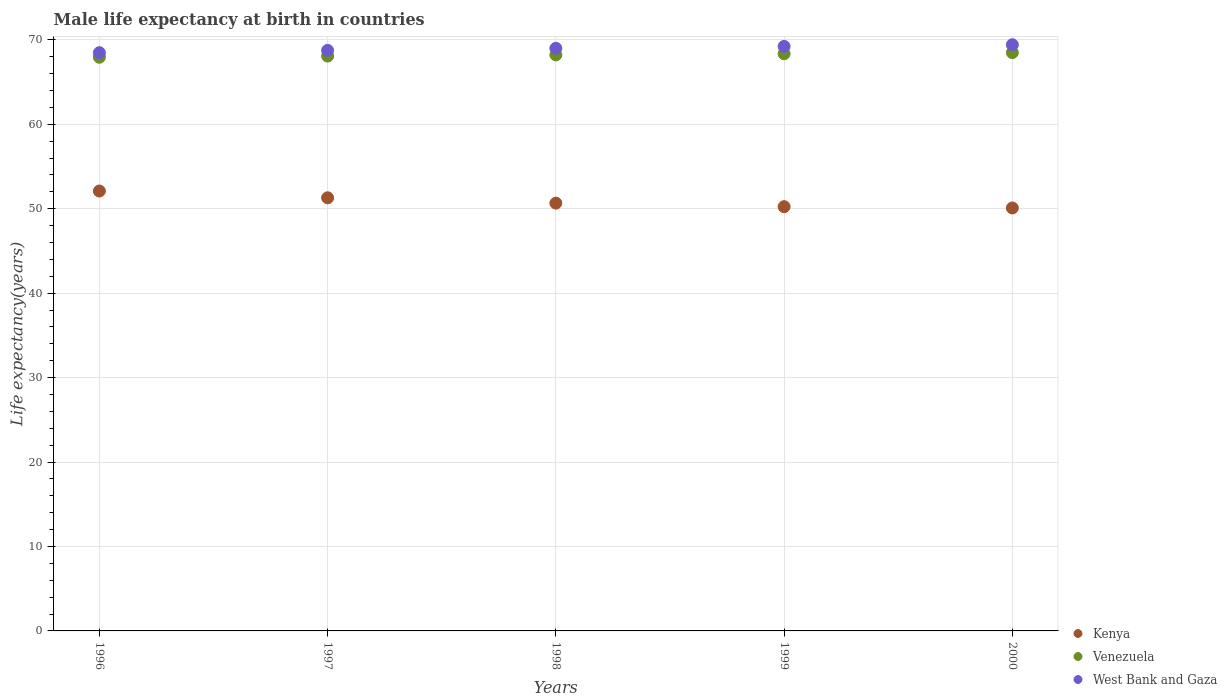How many different coloured dotlines are there?
Your answer should be very brief. 3. What is the male life expectancy at birth in Kenya in 1996?
Your response must be concise. 52.1. Across all years, what is the maximum male life expectancy at birth in Kenya?
Offer a terse response. 52.1. Across all years, what is the minimum male life expectancy at birth in Venezuela?
Offer a very short reply. 67.94. In which year was the male life expectancy at birth in West Bank and Gaza maximum?
Give a very brief answer. 2000. What is the total male life expectancy at birth in Kenya in the graph?
Ensure brevity in your answer.  254.4. What is the difference between the male life expectancy at birth in West Bank and Gaza in 1997 and that in 1999?
Give a very brief answer. -0.47. What is the difference between the male life expectancy at birth in Kenya in 1999 and the male life expectancy at birth in Venezuela in 2000?
Offer a very short reply. -18.24. What is the average male life expectancy at birth in West Bank and Gaza per year?
Provide a short and direct response. 68.98. In the year 1999, what is the difference between the male life expectancy at birth in Venezuela and male life expectancy at birth in Kenya?
Ensure brevity in your answer.  18.11. What is the ratio of the male life expectancy at birth in Kenya in 1998 to that in 1999?
Offer a terse response. 1.01. Is the difference between the male life expectancy at birth in Venezuela in 1997 and 2000 greater than the difference between the male life expectancy at birth in Kenya in 1997 and 2000?
Provide a succinct answer. No. What is the difference between the highest and the second highest male life expectancy at birth in Venezuela?
Provide a succinct answer. 0.13. What is the difference between the highest and the lowest male life expectancy at birth in Kenya?
Offer a very short reply. 2.01. In how many years, is the male life expectancy at birth in West Bank and Gaza greater than the average male life expectancy at birth in West Bank and Gaza taken over all years?
Ensure brevity in your answer.  3. Is the sum of the male life expectancy at birth in West Bank and Gaza in 1996 and 1997 greater than the maximum male life expectancy at birth in Venezuela across all years?
Your answer should be very brief. Yes. Does the male life expectancy at birth in Venezuela monotonically increase over the years?
Give a very brief answer. Yes. Is the male life expectancy at birth in Venezuela strictly greater than the male life expectancy at birth in Kenya over the years?
Offer a terse response. Yes. How many dotlines are there?
Your answer should be compact. 3. How many years are there in the graph?
Give a very brief answer. 5. What is the difference between two consecutive major ticks on the Y-axis?
Ensure brevity in your answer.  10. Are the values on the major ticks of Y-axis written in scientific E-notation?
Offer a terse response. No. How many legend labels are there?
Give a very brief answer. 3. How are the legend labels stacked?
Offer a very short reply. Vertical. What is the title of the graph?
Your response must be concise. Male life expectancy at birth in countries. What is the label or title of the Y-axis?
Ensure brevity in your answer.  Life expectancy(years). What is the Life expectancy(years) in Kenya in 1996?
Keep it short and to the point. 52.1. What is the Life expectancy(years) in Venezuela in 1996?
Provide a succinct answer. 67.94. What is the Life expectancy(years) of West Bank and Gaza in 1996?
Provide a short and direct response. 68.48. What is the Life expectancy(years) in Kenya in 1997?
Ensure brevity in your answer.  51.3. What is the Life expectancy(years) in Venezuela in 1997?
Your answer should be compact. 68.08. What is the Life expectancy(years) of West Bank and Gaza in 1997?
Offer a very short reply. 68.76. What is the Life expectancy(years) of Kenya in 1998?
Offer a terse response. 50.67. What is the Life expectancy(years) in Venezuela in 1998?
Your answer should be very brief. 68.22. What is the Life expectancy(years) in West Bank and Gaza in 1998?
Give a very brief answer. 69.01. What is the Life expectancy(years) in Kenya in 1999?
Offer a very short reply. 50.25. What is the Life expectancy(years) of Venezuela in 1999?
Give a very brief answer. 68.36. What is the Life expectancy(years) of West Bank and Gaza in 1999?
Provide a short and direct response. 69.23. What is the Life expectancy(years) of Kenya in 2000?
Your answer should be compact. 50.09. What is the Life expectancy(years) in Venezuela in 2000?
Offer a very short reply. 68.49. What is the Life expectancy(years) in West Bank and Gaza in 2000?
Offer a terse response. 69.43. Across all years, what is the maximum Life expectancy(years) in Kenya?
Provide a short and direct response. 52.1. Across all years, what is the maximum Life expectancy(years) in Venezuela?
Make the answer very short. 68.49. Across all years, what is the maximum Life expectancy(years) in West Bank and Gaza?
Provide a succinct answer. 69.43. Across all years, what is the minimum Life expectancy(years) of Kenya?
Ensure brevity in your answer.  50.09. Across all years, what is the minimum Life expectancy(years) in Venezuela?
Keep it short and to the point. 67.94. Across all years, what is the minimum Life expectancy(years) in West Bank and Gaza?
Offer a terse response. 68.48. What is the total Life expectancy(years) of Kenya in the graph?
Ensure brevity in your answer.  254.4. What is the total Life expectancy(years) in Venezuela in the graph?
Provide a short and direct response. 341.1. What is the total Life expectancy(years) in West Bank and Gaza in the graph?
Give a very brief answer. 344.9. What is the difference between the Life expectancy(years) of Kenya in 1996 and that in 1997?
Offer a terse response. 0.8. What is the difference between the Life expectancy(years) in Venezuela in 1996 and that in 1997?
Your answer should be very brief. -0.14. What is the difference between the Life expectancy(years) of West Bank and Gaza in 1996 and that in 1997?
Keep it short and to the point. -0.27. What is the difference between the Life expectancy(years) of Kenya in 1996 and that in 1998?
Your answer should be very brief. 1.43. What is the difference between the Life expectancy(years) in Venezuela in 1996 and that in 1998?
Offer a terse response. -0.28. What is the difference between the Life expectancy(years) in West Bank and Gaza in 1996 and that in 1998?
Ensure brevity in your answer.  -0.52. What is the difference between the Life expectancy(years) of Kenya in 1996 and that in 1999?
Provide a succinct answer. 1.85. What is the difference between the Life expectancy(years) of Venezuela in 1996 and that in 1999?
Your response must be concise. -0.41. What is the difference between the Life expectancy(years) of West Bank and Gaza in 1996 and that in 1999?
Your answer should be very brief. -0.74. What is the difference between the Life expectancy(years) in Kenya in 1996 and that in 2000?
Ensure brevity in your answer.  2.01. What is the difference between the Life expectancy(years) of Venezuela in 1996 and that in 2000?
Offer a very short reply. -0.55. What is the difference between the Life expectancy(years) of West Bank and Gaza in 1996 and that in 2000?
Ensure brevity in your answer.  -0.94. What is the difference between the Life expectancy(years) in Kenya in 1997 and that in 1998?
Make the answer very short. 0.63. What is the difference between the Life expectancy(years) of Venezuela in 1997 and that in 1998?
Provide a succinct answer. -0.14. What is the difference between the Life expectancy(years) in West Bank and Gaza in 1997 and that in 1998?
Your answer should be compact. -0.25. What is the difference between the Life expectancy(years) of Kenya in 1997 and that in 1999?
Your response must be concise. 1.05. What is the difference between the Life expectancy(years) of Venezuela in 1997 and that in 1999?
Keep it short and to the point. -0.27. What is the difference between the Life expectancy(years) in West Bank and Gaza in 1997 and that in 1999?
Your answer should be very brief. -0.47. What is the difference between the Life expectancy(years) of Kenya in 1997 and that in 2000?
Give a very brief answer. 1.21. What is the difference between the Life expectancy(years) of Venezuela in 1997 and that in 2000?
Your response must be concise. -0.41. What is the difference between the Life expectancy(years) of West Bank and Gaza in 1997 and that in 2000?
Give a very brief answer. -0.67. What is the difference between the Life expectancy(years) in Kenya in 1998 and that in 1999?
Offer a very short reply. 0.42. What is the difference between the Life expectancy(years) in Venezuela in 1998 and that in 1999?
Provide a succinct answer. -0.14. What is the difference between the Life expectancy(years) of West Bank and Gaza in 1998 and that in 1999?
Keep it short and to the point. -0.22. What is the difference between the Life expectancy(years) in Kenya in 1998 and that in 2000?
Your answer should be very brief. 0.57. What is the difference between the Life expectancy(years) in Venezuela in 1998 and that in 2000?
Provide a succinct answer. -0.27. What is the difference between the Life expectancy(years) in West Bank and Gaza in 1998 and that in 2000?
Your response must be concise. -0.42. What is the difference between the Life expectancy(years) of Kenya in 1999 and that in 2000?
Make the answer very short. 0.15. What is the difference between the Life expectancy(years) in Venezuela in 1999 and that in 2000?
Give a very brief answer. -0.13. What is the difference between the Life expectancy(years) of West Bank and Gaza in 1999 and that in 2000?
Keep it short and to the point. -0.2. What is the difference between the Life expectancy(years) in Kenya in 1996 and the Life expectancy(years) in Venezuela in 1997?
Provide a short and direct response. -15.98. What is the difference between the Life expectancy(years) of Kenya in 1996 and the Life expectancy(years) of West Bank and Gaza in 1997?
Your answer should be very brief. -16.66. What is the difference between the Life expectancy(years) in Venezuela in 1996 and the Life expectancy(years) in West Bank and Gaza in 1997?
Keep it short and to the point. -0.81. What is the difference between the Life expectancy(years) of Kenya in 1996 and the Life expectancy(years) of Venezuela in 1998?
Keep it short and to the point. -16.12. What is the difference between the Life expectancy(years) in Kenya in 1996 and the Life expectancy(years) in West Bank and Gaza in 1998?
Your response must be concise. -16.91. What is the difference between the Life expectancy(years) in Venezuela in 1996 and the Life expectancy(years) in West Bank and Gaza in 1998?
Provide a short and direct response. -1.06. What is the difference between the Life expectancy(years) in Kenya in 1996 and the Life expectancy(years) in Venezuela in 1999?
Offer a very short reply. -16.26. What is the difference between the Life expectancy(years) of Kenya in 1996 and the Life expectancy(years) of West Bank and Gaza in 1999?
Give a very brief answer. -17.13. What is the difference between the Life expectancy(years) in Venezuela in 1996 and the Life expectancy(years) in West Bank and Gaza in 1999?
Provide a succinct answer. -1.28. What is the difference between the Life expectancy(years) in Kenya in 1996 and the Life expectancy(years) in Venezuela in 2000?
Provide a short and direct response. -16.39. What is the difference between the Life expectancy(years) of Kenya in 1996 and the Life expectancy(years) of West Bank and Gaza in 2000?
Ensure brevity in your answer.  -17.33. What is the difference between the Life expectancy(years) of Venezuela in 1996 and the Life expectancy(years) of West Bank and Gaza in 2000?
Your answer should be very brief. -1.48. What is the difference between the Life expectancy(years) in Kenya in 1997 and the Life expectancy(years) in Venezuela in 1998?
Keep it short and to the point. -16.92. What is the difference between the Life expectancy(years) of Kenya in 1997 and the Life expectancy(years) of West Bank and Gaza in 1998?
Make the answer very short. -17.71. What is the difference between the Life expectancy(years) in Venezuela in 1997 and the Life expectancy(years) in West Bank and Gaza in 1998?
Your response must be concise. -0.92. What is the difference between the Life expectancy(years) in Kenya in 1997 and the Life expectancy(years) in Venezuela in 1999?
Make the answer very short. -17.06. What is the difference between the Life expectancy(years) of Kenya in 1997 and the Life expectancy(years) of West Bank and Gaza in 1999?
Your answer should be compact. -17.93. What is the difference between the Life expectancy(years) in Venezuela in 1997 and the Life expectancy(years) in West Bank and Gaza in 1999?
Keep it short and to the point. -1.15. What is the difference between the Life expectancy(years) in Kenya in 1997 and the Life expectancy(years) in Venezuela in 2000?
Ensure brevity in your answer.  -17.19. What is the difference between the Life expectancy(years) of Kenya in 1997 and the Life expectancy(years) of West Bank and Gaza in 2000?
Make the answer very short. -18.13. What is the difference between the Life expectancy(years) of Venezuela in 1997 and the Life expectancy(years) of West Bank and Gaza in 2000?
Your response must be concise. -1.34. What is the difference between the Life expectancy(years) in Kenya in 1998 and the Life expectancy(years) in Venezuela in 1999?
Your answer should be very brief. -17.69. What is the difference between the Life expectancy(years) in Kenya in 1998 and the Life expectancy(years) in West Bank and Gaza in 1999?
Ensure brevity in your answer.  -18.56. What is the difference between the Life expectancy(years) of Venezuela in 1998 and the Life expectancy(years) of West Bank and Gaza in 1999?
Ensure brevity in your answer.  -1.01. What is the difference between the Life expectancy(years) of Kenya in 1998 and the Life expectancy(years) of Venezuela in 2000?
Provide a short and direct response. -17.82. What is the difference between the Life expectancy(years) in Kenya in 1998 and the Life expectancy(years) in West Bank and Gaza in 2000?
Provide a short and direct response. -18.76. What is the difference between the Life expectancy(years) in Venezuela in 1998 and the Life expectancy(years) in West Bank and Gaza in 2000?
Provide a succinct answer. -1.21. What is the difference between the Life expectancy(years) in Kenya in 1999 and the Life expectancy(years) in Venezuela in 2000?
Your answer should be very brief. -18.24. What is the difference between the Life expectancy(years) of Kenya in 1999 and the Life expectancy(years) of West Bank and Gaza in 2000?
Provide a succinct answer. -19.18. What is the difference between the Life expectancy(years) of Venezuela in 1999 and the Life expectancy(years) of West Bank and Gaza in 2000?
Your answer should be very brief. -1.07. What is the average Life expectancy(years) in Kenya per year?
Offer a very short reply. 50.88. What is the average Life expectancy(years) in Venezuela per year?
Provide a short and direct response. 68.22. What is the average Life expectancy(years) in West Bank and Gaza per year?
Ensure brevity in your answer.  68.98. In the year 1996, what is the difference between the Life expectancy(years) of Kenya and Life expectancy(years) of Venezuela?
Give a very brief answer. -15.84. In the year 1996, what is the difference between the Life expectancy(years) in Kenya and Life expectancy(years) in West Bank and Gaza?
Your answer should be very brief. -16.39. In the year 1996, what is the difference between the Life expectancy(years) of Venezuela and Life expectancy(years) of West Bank and Gaza?
Give a very brief answer. -0.54. In the year 1997, what is the difference between the Life expectancy(years) in Kenya and Life expectancy(years) in Venezuela?
Offer a very short reply. -16.78. In the year 1997, what is the difference between the Life expectancy(years) of Kenya and Life expectancy(years) of West Bank and Gaza?
Provide a short and direct response. -17.46. In the year 1997, what is the difference between the Life expectancy(years) in Venezuela and Life expectancy(years) in West Bank and Gaza?
Your response must be concise. -0.68. In the year 1998, what is the difference between the Life expectancy(years) of Kenya and Life expectancy(years) of Venezuela?
Your answer should be very brief. -17.55. In the year 1998, what is the difference between the Life expectancy(years) of Kenya and Life expectancy(years) of West Bank and Gaza?
Your answer should be compact. -18.34. In the year 1998, what is the difference between the Life expectancy(years) of Venezuela and Life expectancy(years) of West Bank and Gaza?
Give a very brief answer. -0.79. In the year 1999, what is the difference between the Life expectancy(years) in Kenya and Life expectancy(years) in Venezuela?
Ensure brevity in your answer.  -18.11. In the year 1999, what is the difference between the Life expectancy(years) in Kenya and Life expectancy(years) in West Bank and Gaza?
Your response must be concise. -18.98. In the year 1999, what is the difference between the Life expectancy(years) of Venezuela and Life expectancy(years) of West Bank and Gaza?
Ensure brevity in your answer.  -0.87. In the year 2000, what is the difference between the Life expectancy(years) in Kenya and Life expectancy(years) in Venezuela?
Your response must be concise. -18.4. In the year 2000, what is the difference between the Life expectancy(years) in Kenya and Life expectancy(years) in West Bank and Gaza?
Provide a short and direct response. -19.33. In the year 2000, what is the difference between the Life expectancy(years) in Venezuela and Life expectancy(years) in West Bank and Gaza?
Your answer should be very brief. -0.94. What is the ratio of the Life expectancy(years) of Kenya in 1996 to that in 1997?
Make the answer very short. 1.02. What is the ratio of the Life expectancy(years) of West Bank and Gaza in 1996 to that in 1997?
Your answer should be compact. 1. What is the ratio of the Life expectancy(years) of Kenya in 1996 to that in 1998?
Offer a terse response. 1.03. What is the ratio of the Life expectancy(years) of Kenya in 1996 to that in 1999?
Provide a succinct answer. 1.04. What is the ratio of the Life expectancy(years) in West Bank and Gaza in 1996 to that in 1999?
Your answer should be very brief. 0.99. What is the ratio of the Life expectancy(years) in Kenya in 1996 to that in 2000?
Keep it short and to the point. 1.04. What is the ratio of the Life expectancy(years) in West Bank and Gaza in 1996 to that in 2000?
Offer a very short reply. 0.99. What is the ratio of the Life expectancy(years) of Kenya in 1997 to that in 1998?
Make the answer very short. 1.01. What is the ratio of the Life expectancy(years) in West Bank and Gaza in 1997 to that in 1998?
Ensure brevity in your answer.  1. What is the ratio of the Life expectancy(years) in Kenya in 1997 to that in 1999?
Provide a succinct answer. 1.02. What is the ratio of the Life expectancy(years) in Kenya in 1997 to that in 2000?
Offer a terse response. 1.02. What is the ratio of the Life expectancy(years) of West Bank and Gaza in 1997 to that in 2000?
Offer a terse response. 0.99. What is the ratio of the Life expectancy(years) in Kenya in 1998 to that in 1999?
Make the answer very short. 1.01. What is the ratio of the Life expectancy(years) in Venezuela in 1998 to that in 1999?
Offer a terse response. 1. What is the ratio of the Life expectancy(years) of West Bank and Gaza in 1998 to that in 1999?
Offer a terse response. 1. What is the ratio of the Life expectancy(years) in Kenya in 1998 to that in 2000?
Your response must be concise. 1.01. What is the ratio of the Life expectancy(years) in Venezuela in 1998 to that in 2000?
Your answer should be very brief. 1. What is the ratio of the Life expectancy(years) of Kenya in 1999 to that in 2000?
Your answer should be compact. 1. What is the ratio of the Life expectancy(years) of Venezuela in 1999 to that in 2000?
Your response must be concise. 1. What is the difference between the highest and the second highest Life expectancy(years) of Kenya?
Ensure brevity in your answer.  0.8. What is the difference between the highest and the second highest Life expectancy(years) of Venezuela?
Keep it short and to the point. 0.13. What is the difference between the highest and the second highest Life expectancy(years) of West Bank and Gaza?
Offer a terse response. 0.2. What is the difference between the highest and the lowest Life expectancy(years) in Kenya?
Give a very brief answer. 2.01. What is the difference between the highest and the lowest Life expectancy(years) in Venezuela?
Offer a terse response. 0.55. What is the difference between the highest and the lowest Life expectancy(years) in West Bank and Gaza?
Ensure brevity in your answer.  0.94. 